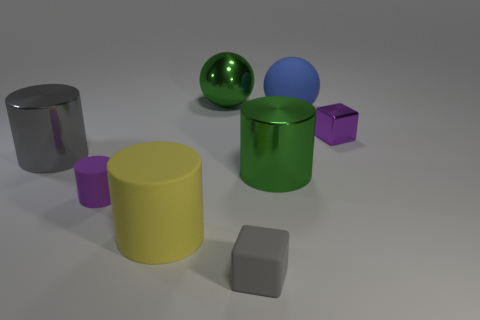The thing that is the same color as the small metallic block is what shape?
Your answer should be compact. Cylinder. There is a matte sphere that is the same size as the green metal cylinder; what is its color?
Give a very brief answer. Blue. How many other objects are the same color as the large rubber ball?
Provide a short and direct response. 0. Is the number of objects that are to the left of the big blue ball greater than the number of things?
Your response must be concise. No. Do the green ball and the small gray block have the same material?
Your answer should be very brief. No. How many things are either green things behind the large green cylinder or small purple spheres?
Ensure brevity in your answer.  1. How many other objects are the same size as the gray rubber block?
Keep it short and to the point. 2. Are there an equal number of blue objects that are in front of the large gray metal cylinder and large yellow matte things behind the blue matte ball?
Make the answer very short. Yes. What color is the metal object that is the same shape as the blue rubber thing?
Your answer should be very brief. Green. Is there any other thing that is the same shape as the gray shiny object?
Provide a short and direct response. Yes. 